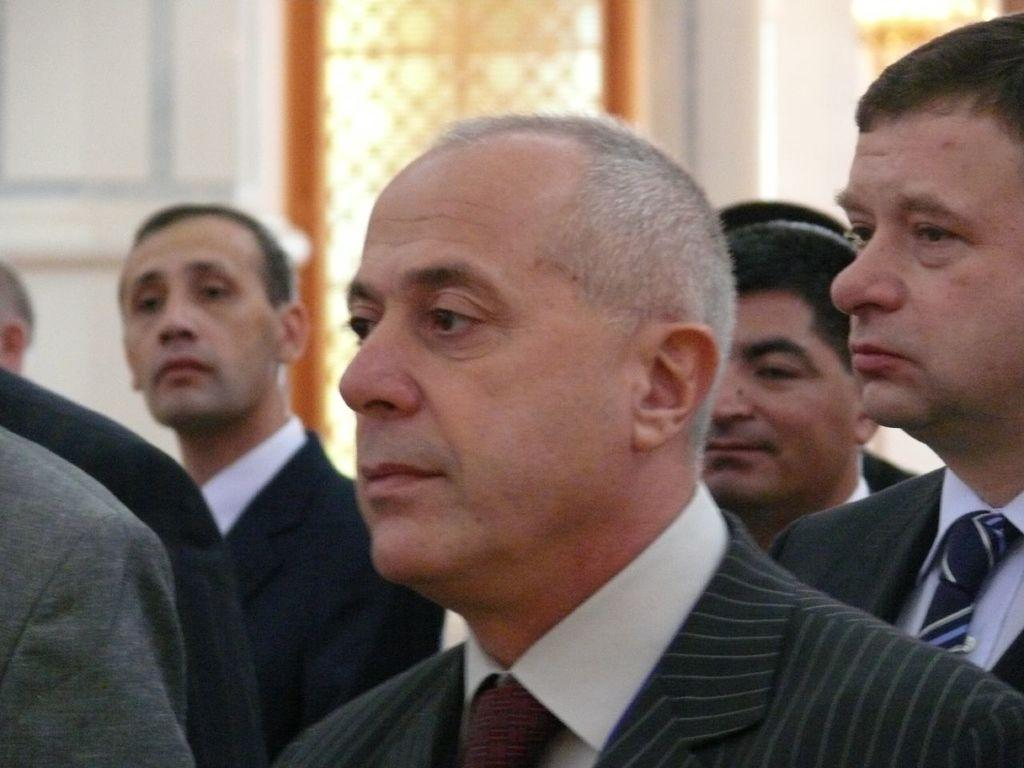What is the main subject of the image? The main subject of the image is a group of men. Where are the men located in the image? The men are standing in a place. What are the men wearing in the image? All the men are wearing suits. How many fingers can be seen on the men's hands in the image? The number of fingers on the men's hands cannot be determined from the image, as hands are not visible. What season is it in the image, considering the men are wearing suits? The image does not provide any information about the season, and the men's suits do not necessarily indicate a specific season. 